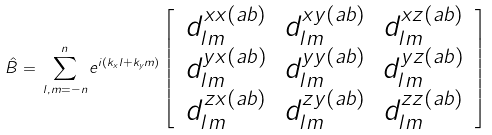Convert formula to latex. <formula><loc_0><loc_0><loc_500><loc_500>\hat { B } = \, \sum _ { l , m = - n } ^ { n } e ^ { i ( k _ { x } l + k _ { y } m ) } \left [ \, \begin{array} { c c c } d _ { l m } ^ { x x ( a b ) } & d _ { l m } ^ { x y ( a b ) } & d _ { l m } ^ { x z ( a b ) } \\ d _ { l m } ^ { y x ( a b ) } & d _ { l m } ^ { y y ( a b ) } & d _ { l m } ^ { y z ( a b ) } \\ d _ { l m } ^ { z x ( a b ) } & d _ { l m } ^ { z y ( a b ) } & d _ { l m } ^ { z z ( a b ) } \end{array} \, \right ]</formula> 